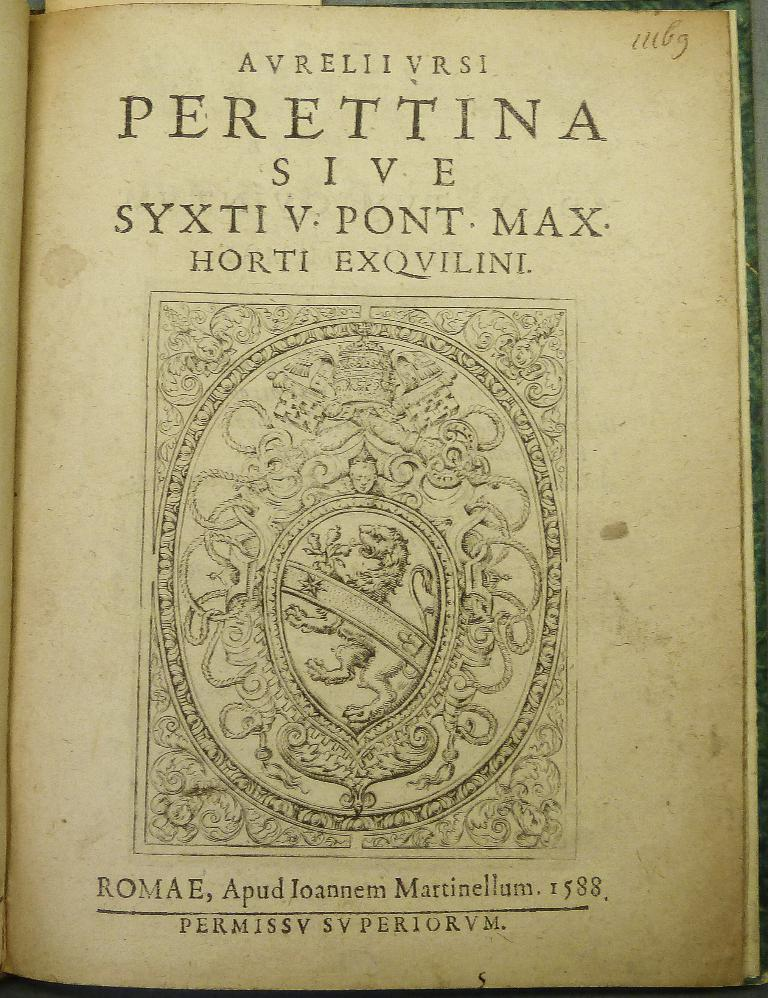<image>
Write a terse but informative summary of the picture. An old book is open to the title page which says Avrellivrsi Perettina at the top. 